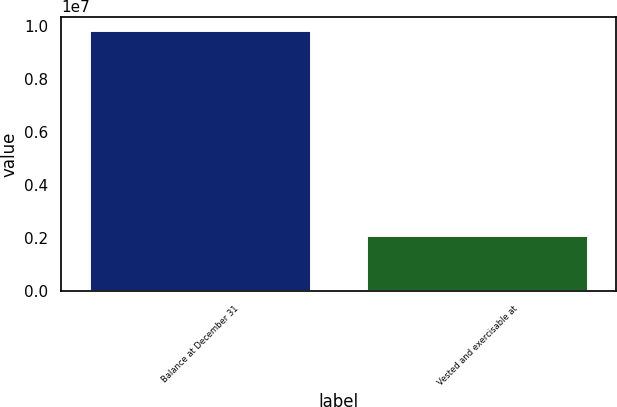Convert chart. <chart><loc_0><loc_0><loc_500><loc_500><bar_chart><fcel>Balance at December 31<fcel>Vested and exercisable at<nl><fcel>9.85295e+06<fcel>2.10891e+06<nl></chart> 